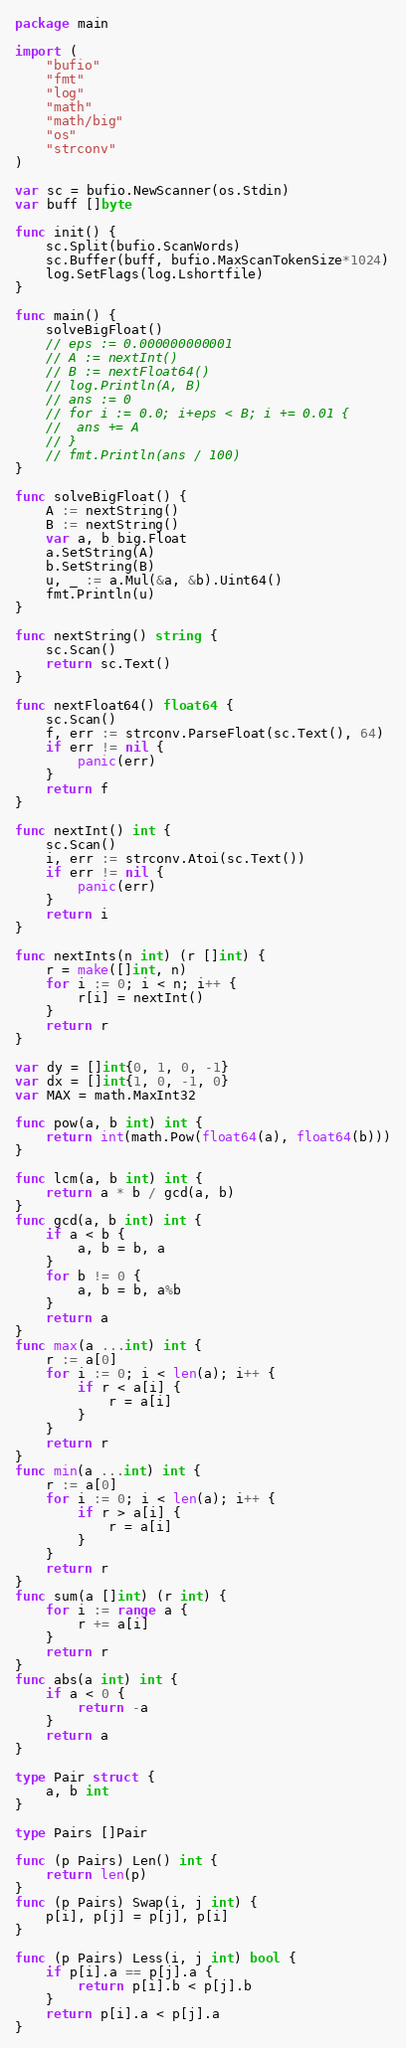<code> <loc_0><loc_0><loc_500><loc_500><_Go_>package main

import (
	"bufio"
	"fmt"
	"log"
	"math"
	"math/big"
	"os"
	"strconv"
)

var sc = bufio.NewScanner(os.Stdin)
var buff []byte

func init() {
	sc.Split(bufio.ScanWords)
	sc.Buffer(buff, bufio.MaxScanTokenSize*1024)
	log.SetFlags(log.Lshortfile)
}

func main() {
	solveBigFloat()
	// eps := 0.000000000001
	// A := nextInt()
	// B := nextFloat64()
	// log.Println(A, B)
	// ans := 0
	// for i := 0.0; i+eps < B; i += 0.01 {
	// 	ans += A
	// }
	// fmt.Println(ans / 100)
}

func solveBigFloat() {
	A := nextString()
	B := nextString()
	var a, b big.Float
	a.SetString(A)
	b.SetString(B)
	u, _ := a.Mul(&a, &b).Uint64()
	fmt.Println(u)
}

func nextString() string {
	sc.Scan()
	return sc.Text()
}

func nextFloat64() float64 {
	sc.Scan()
	f, err := strconv.ParseFloat(sc.Text(), 64)
	if err != nil {
		panic(err)
	}
	return f
}

func nextInt() int {
	sc.Scan()
	i, err := strconv.Atoi(sc.Text())
	if err != nil {
		panic(err)
	}
	return i
}

func nextInts(n int) (r []int) {
	r = make([]int, n)
	for i := 0; i < n; i++ {
		r[i] = nextInt()
	}
	return r
}

var dy = []int{0, 1, 0, -1}
var dx = []int{1, 0, -1, 0}
var MAX = math.MaxInt32

func pow(a, b int) int {
	return int(math.Pow(float64(a), float64(b)))
}

func lcm(a, b int) int {
	return a * b / gcd(a, b)
}
func gcd(a, b int) int {
	if a < b {
		a, b = b, a
	}
	for b != 0 {
		a, b = b, a%b
	}
	return a
}
func max(a ...int) int {
	r := a[0]
	for i := 0; i < len(a); i++ {
		if r < a[i] {
			r = a[i]
		}
	}
	return r
}
func min(a ...int) int {
	r := a[0]
	for i := 0; i < len(a); i++ {
		if r > a[i] {
			r = a[i]
		}
	}
	return r
}
func sum(a []int) (r int) {
	for i := range a {
		r += a[i]
	}
	return r
}
func abs(a int) int {
	if a < 0 {
		return -a
	}
	return a
}

type Pair struct {
	a, b int
}

type Pairs []Pair

func (p Pairs) Len() int {
	return len(p)
}
func (p Pairs) Swap(i, j int) {
	p[i], p[j] = p[j], p[i]
}

func (p Pairs) Less(i, j int) bool {
	if p[i].a == p[j].a {
		return p[i].b < p[j].b
	}
	return p[i].a < p[j].a
}
</code> 